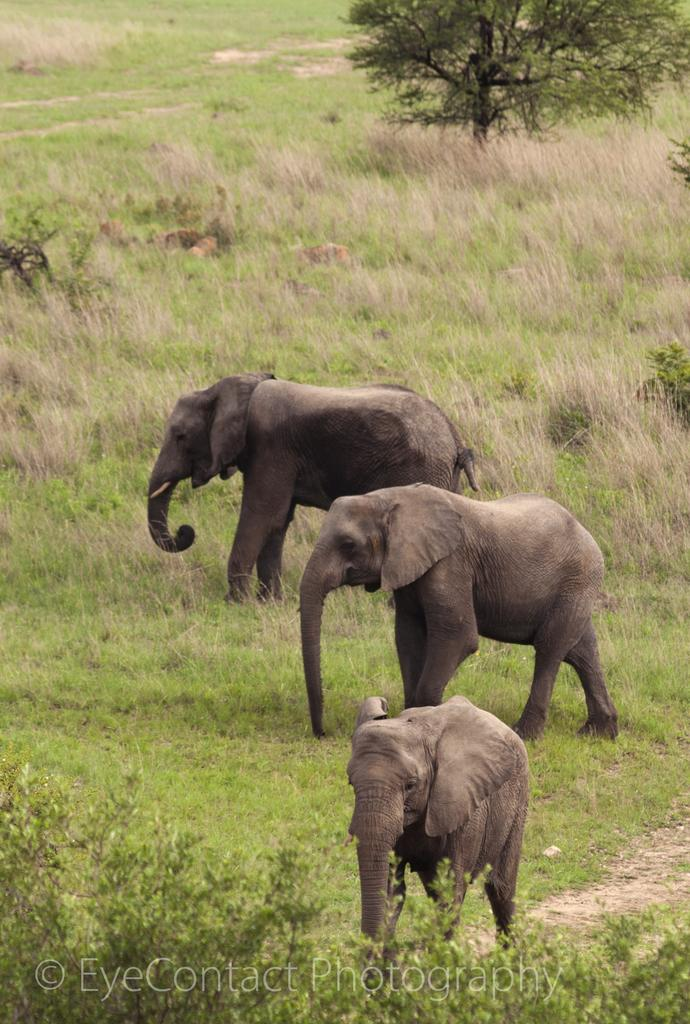How many elephants are present in the image? There are three elephants in the image. What is the position of the elephants in the image? The elephants are standing on the ground. What can be seen in the background of the image? There is grass, plants, and trees in the background of the image. What type of argument can be heard between the elephants in the image? There is no indication of an argument or any sound in the image, as it only shows three elephants standing on the ground. 